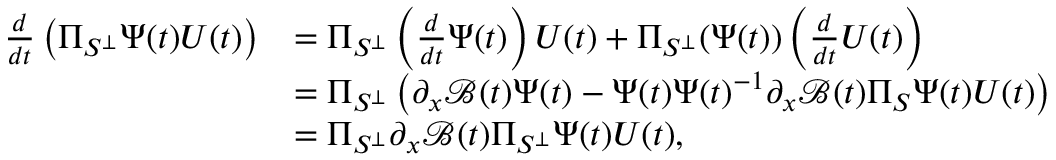<formula> <loc_0><loc_0><loc_500><loc_500>\begin{array} { r l } { \frac { d } { d t } \left ( \Pi _ { S ^ { \perp } } \Psi ( t ) U ( t ) \right ) } & { = \Pi _ { S ^ { \perp } } \left ( \frac { d } { d t } \Psi ( t ) \right ) U ( t ) + \Pi _ { S ^ { \perp } } ( \Psi ( t ) ) \left ( \frac { d } { d t } U ( t ) \right ) } \\ & { = \Pi _ { S ^ { \perp } } \left ( \partial _ { x } \mathcal { B } ( t ) \Psi ( t ) - \Psi ( t ) \Psi ( t ) ^ { - 1 } \partial _ { x } \mathcal { B } ( t ) \Pi _ { S } \Psi ( t ) U ( t ) \right ) } \\ & { = \Pi _ { S ^ { \perp } } \partial _ { x } \mathcal { B } ( t ) \Pi _ { S ^ { \perp } } \Psi ( t ) U ( t ) , } \end{array}</formula> 